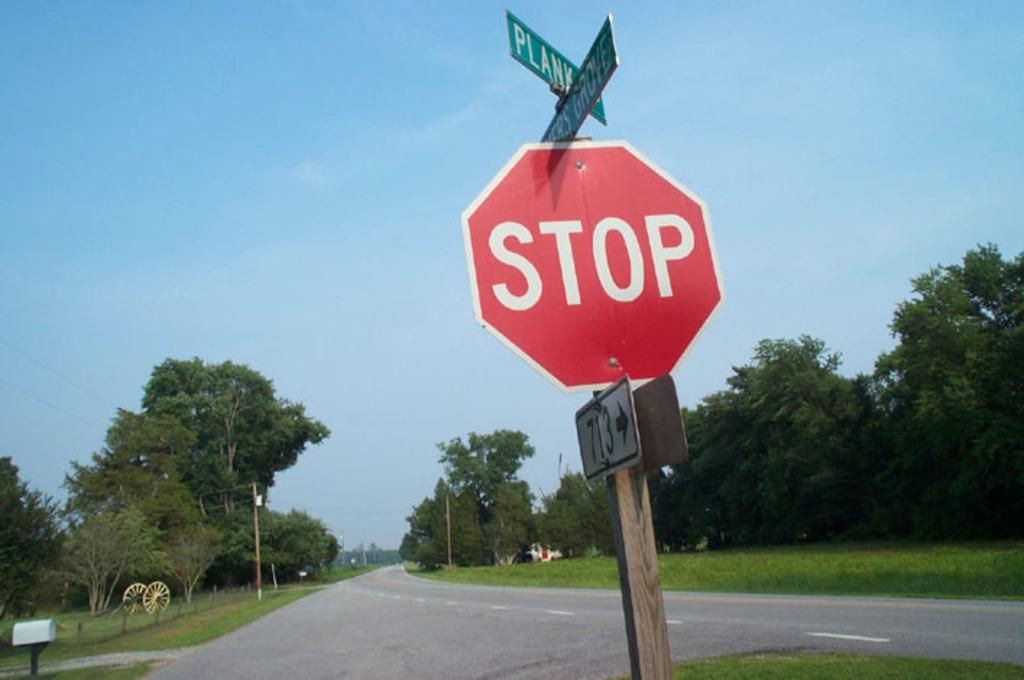<image>
Present a compact description of the photo's key features. a stop sign that is outside and has a green sign above it 